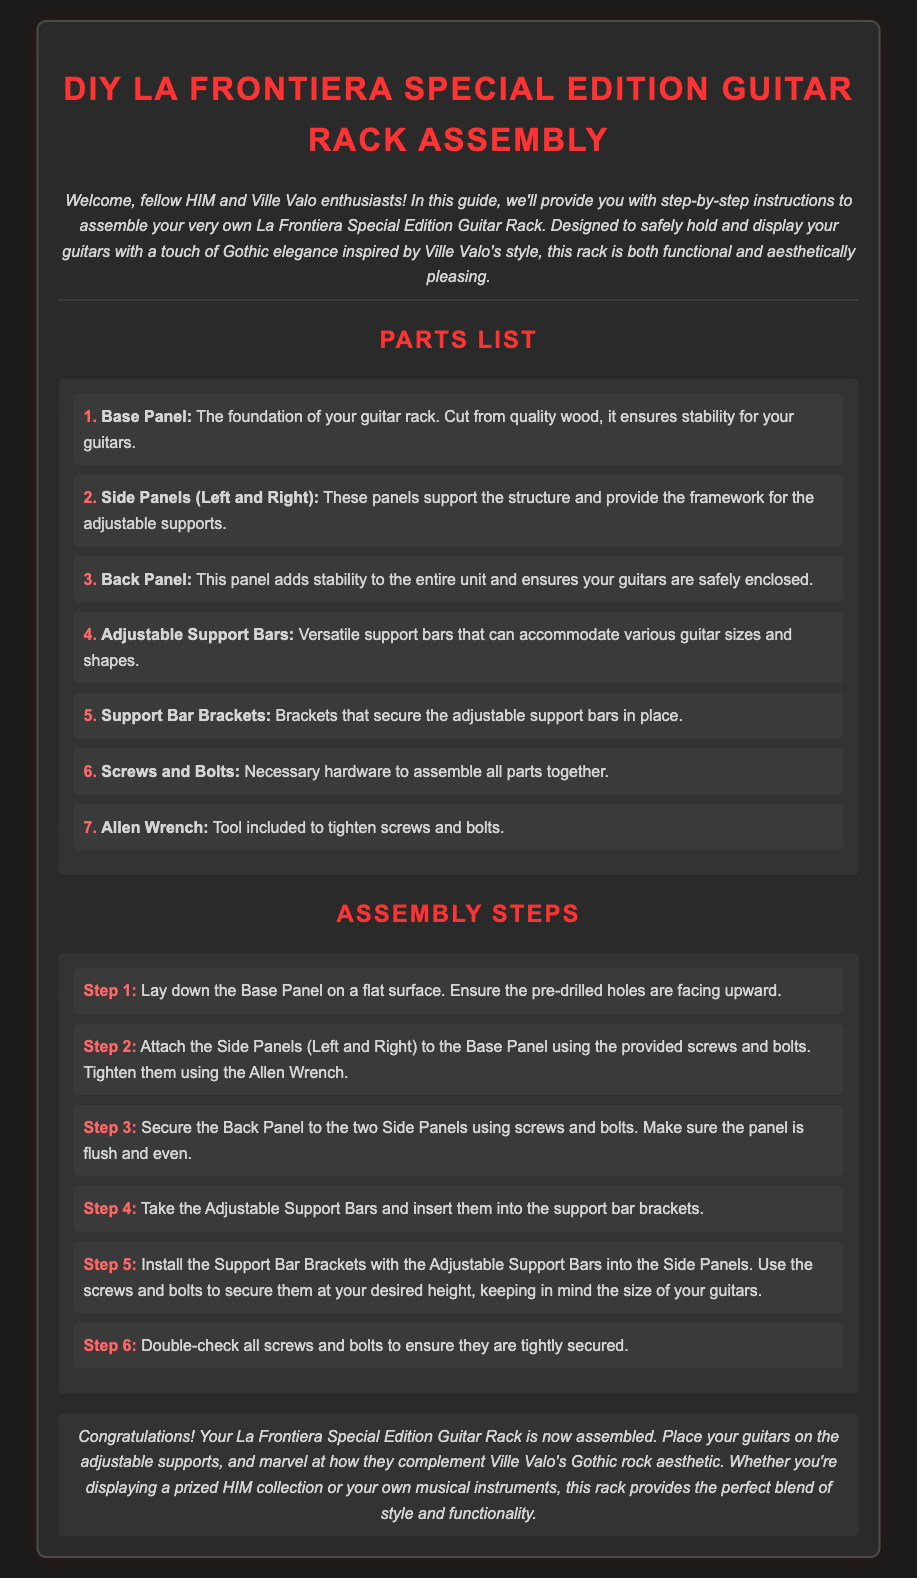what is the title of the document? The title is stated in the heading of the document, which describes the assembly instructions for a specific product.
Answer: DIY La Frontiera Special Edition Guitar Rack Assembly how many parts are listed in the parts list? The document outlines seven specific parts required for the assembly of the guitar rack.
Answer: 7 what is the color of the text for headings? The document specifies the color for headings in the style section, indicating a vibrant color choice.
Answer: #ff3333 what tool is included for tightening screws and bolts? The document mentions a specific tool that is provided with the assembly parts for this purpose.
Answer: Allen Wrench which step involves laying down the Base Panel? The first step indicates the action to be taken regarding the Base Panel at the start of the assembly process.
Answer: Step 1 how should the Support Bar Brackets be installed? The installation involves placing the adjustable support bars into a specific component supporting the structure.
Answer: Into the Side Panels what type of aesthetic does the guitar rack complement? The document describes the style influence of the guitar rack, reflecting a particular musical artist's theme.
Answer: Gothic rock aesthetic why is the Back Panel important in the assembly? The document specifies the function of the Back Panel, highlighting its contribution to the overall stability of the guitar rack.
Answer: Adds stability 